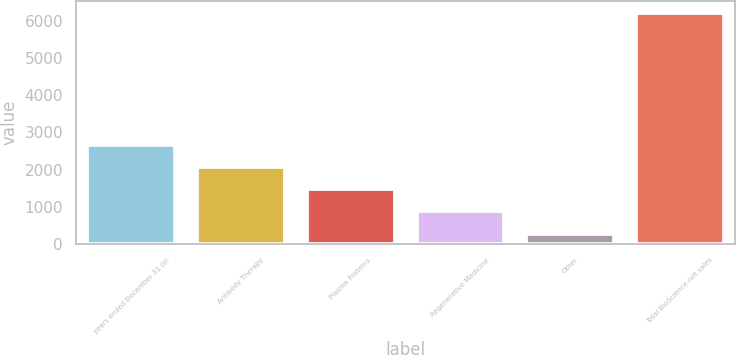Convert chart to OTSL. <chart><loc_0><loc_0><loc_500><loc_500><bar_chart><fcel>years ended December 31 (in<fcel>Antibody Therapy<fcel>Plasma Proteins<fcel>Regenerative Medicine<fcel>Other<fcel>Total BioScience net sales<nl><fcel>2658.6<fcel>2062.2<fcel>1465.8<fcel>869.4<fcel>273<fcel>6237<nl></chart> 